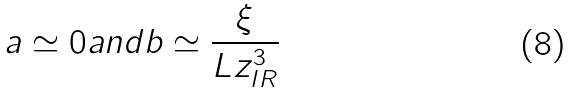Convert formula to latex. <formula><loc_0><loc_0><loc_500><loc_500>a \simeq 0 a n d b \simeq \frac { \xi } { L z _ { I R } ^ { 3 } }</formula> 